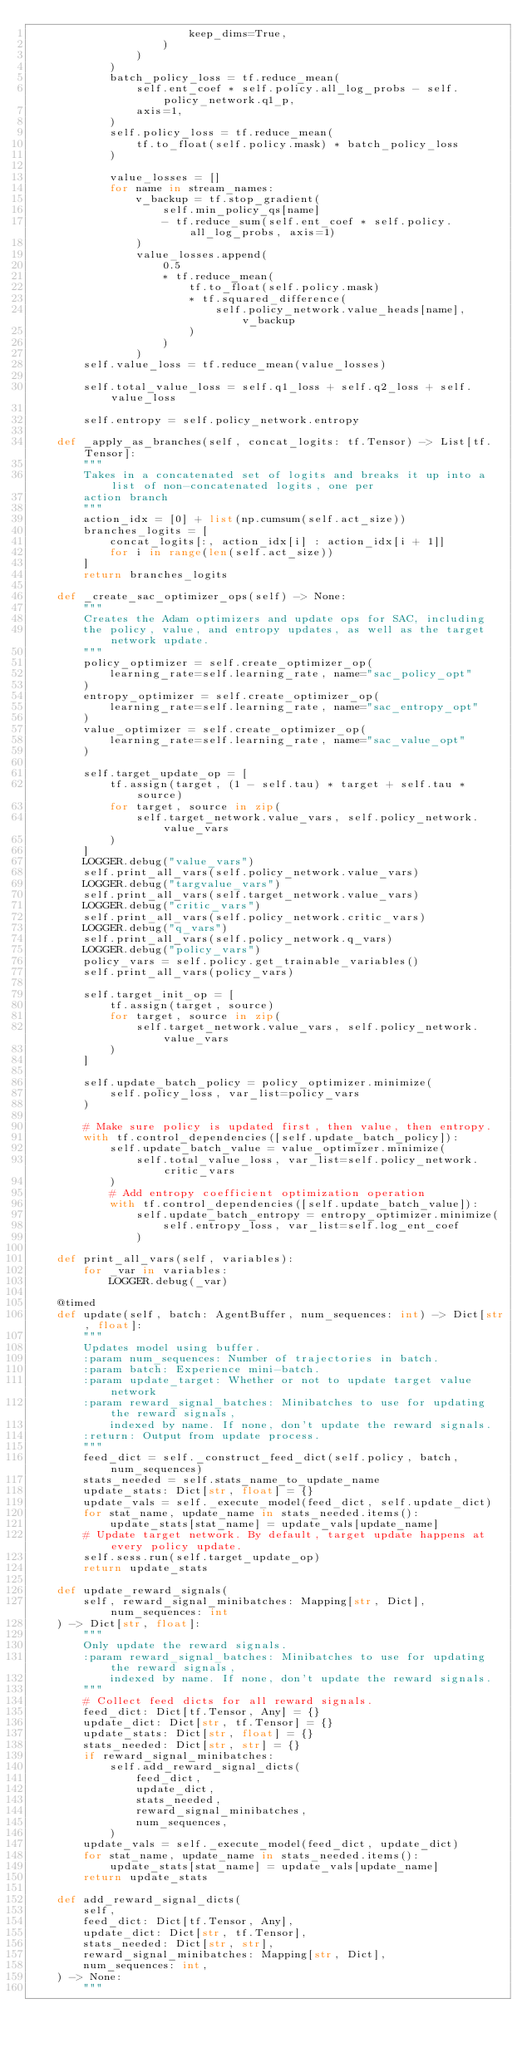Convert code to text. <code><loc_0><loc_0><loc_500><loc_500><_Python_>                        keep_dims=True,
                    )
                )
            )
            batch_policy_loss = tf.reduce_mean(
                self.ent_coef * self.policy.all_log_probs - self.policy_network.q1_p,
                axis=1,
            )
            self.policy_loss = tf.reduce_mean(
                tf.to_float(self.policy.mask) * batch_policy_loss
            )

            value_losses = []
            for name in stream_names:
                v_backup = tf.stop_gradient(
                    self.min_policy_qs[name]
                    - tf.reduce_sum(self.ent_coef * self.policy.all_log_probs, axis=1)
                )
                value_losses.append(
                    0.5
                    * tf.reduce_mean(
                        tf.to_float(self.policy.mask)
                        * tf.squared_difference(
                            self.policy_network.value_heads[name], v_backup
                        )
                    )
                )
        self.value_loss = tf.reduce_mean(value_losses)

        self.total_value_loss = self.q1_loss + self.q2_loss + self.value_loss

        self.entropy = self.policy_network.entropy

    def _apply_as_branches(self, concat_logits: tf.Tensor) -> List[tf.Tensor]:
        """
        Takes in a concatenated set of logits and breaks it up into a list of non-concatenated logits, one per
        action branch
        """
        action_idx = [0] + list(np.cumsum(self.act_size))
        branches_logits = [
            concat_logits[:, action_idx[i] : action_idx[i + 1]]
            for i in range(len(self.act_size))
        ]
        return branches_logits

    def _create_sac_optimizer_ops(self) -> None:
        """
        Creates the Adam optimizers and update ops for SAC, including
        the policy, value, and entropy updates, as well as the target network update.
        """
        policy_optimizer = self.create_optimizer_op(
            learning_rate=self.learning_rate, name="sac_policy_opt"
        )
        entropy_optimizer = self.create_optimizer_op(
            learning_rate=self.learning_rate, name="sac_entropy_opt"
        )
        value_optimizer = self.create_optimizer_op(
            learning_rate=self.learning_rate, name="sac_value_opt"
        )

        self.target_update_op = [
            tf.assign(target, (1 - self.tau) * target + self.tau * source)
            for target, source in zip(
                self.target_network.value_vars, self.policy_network.value_vars
            )
        ]
        LOGGER.debug("value_vars")
        self.print_all_vars(self.policy_network.value_vars)
        LOGGER.debug("targvalue_vars")
        self.print_all_vars(self.target_network.value_vars)
        LOGGER.debug("critic_vars")
        self.print_all_vars(self.policy_network.critic_vars)
        LOGGER.debug("q_vars")
        self.print_all_vars(self.policy_network.q_vars)
        LOGGER.debug("policy_vars")
        policy_vars = self.policy.get_trainable_variables()
        self.print_all_vars(policy_vars)

        self.target_init_op = [
            tf.assign(target, source)
            for target, source in zip(
                self.target_network.value_vars, self.policy_network.value_vars
            )
        ]

        self.update_batch_policy = policy_optimizer.minimize(
            self.policy_loss, var_list=policy_vars
        )

        # Make sure policy is updated first, then value, then entropy.
        with tf.control_dependencies([self.update_batch_policy]):
            self.update_batch_value = value_optimizer.minimize(
                self.total_value_loss, var_list=self.policy_network.critic_vars
            )
            # Add entropy coefficient optimization operation
            with tf.control_dependencies([self.update_batch_value]):
                self.update_batch_entropy = entropy_optimizer.minimize(
                    self.entropy_loss, var_list=self.log_ent_coef
                )

    def print_all_vars(self, variables):
        for _var in variables:
            LOGGER.debug(_var)

    @timed
    def update(self, batch: AgentBuffer, num_sequences: int) -> Dict[str, float]:
        """
        Updates model using buffer.
        :param num_sequences: Number of trajectories in batch.
        :param batch: Experience mini-batch.
        :param update_target: Whether or not to update target value network
        :param reward_signal_batches: Minibatches to use for updating the reward signals,
            indexed by name. If none, don't update the reward signals.
        :return: Output from update process.
        """
        feed_dict = self._construct_feed_dict(self.policy, batch, num_sequences)
        stats_needed = self.stats_name_to_update_name
        update_stats: Dict[str, float] = {}
        update_vals = self._execute_model(feed_dict, self.update_dict)
        for stat_name, update_name in stats_needed.items():
            update_stats[stat_name] = update_vals[update_name]
        # Update target network. By default, target update happens at every policy update.
        self.sess.run(self.target_update_op)
        return update_stats

    def update_reward_signals(
        self, reward_signal_minibatches: Mapping[str, Dict], num_sequences: int
    ) -> Dict[str, float]:
        """
        Only update the reward signals.
        :param reward_signal_batches: Minibatches to use for updating the reward signals,
            indexed by name. If none, don't update the reward signals.
        """
        # Collect feed dicts for all reward signals.
        feed_dict: Dict[tf.Tensor, Any] = {}
        update_dict: Dict[str, tf.Tensor] = {}
        update_stats: Dict[str, float] = {}
        stats_needed: Dict[str, str] = {}
        if reward_signal_minibatches:
            self.add_reward_signal_dicts(
                feed_dict,
                update_dict,
                stats_needed,
                reward_signal_minibatches,
                num_sequences,
            )
        update_vals = self._execute_model(feed_dict, update_dict)
        for stat_name, update_name in stats_needed.items():
            update_stats[stat_name] = update_vals[update_name]
        return update_stats

    def add_reward_signal_dicts(
        self,
        feed_dict: Dict[tf.Tensor, Any],
        update_dict: Dict[str, tf.Tensor],
        stats_needed: Dict[str, str],
        reward_signal_minibatches: Mapping[str, Dict],
        num_sequences: int,
    ) -> None:
        """</code> 